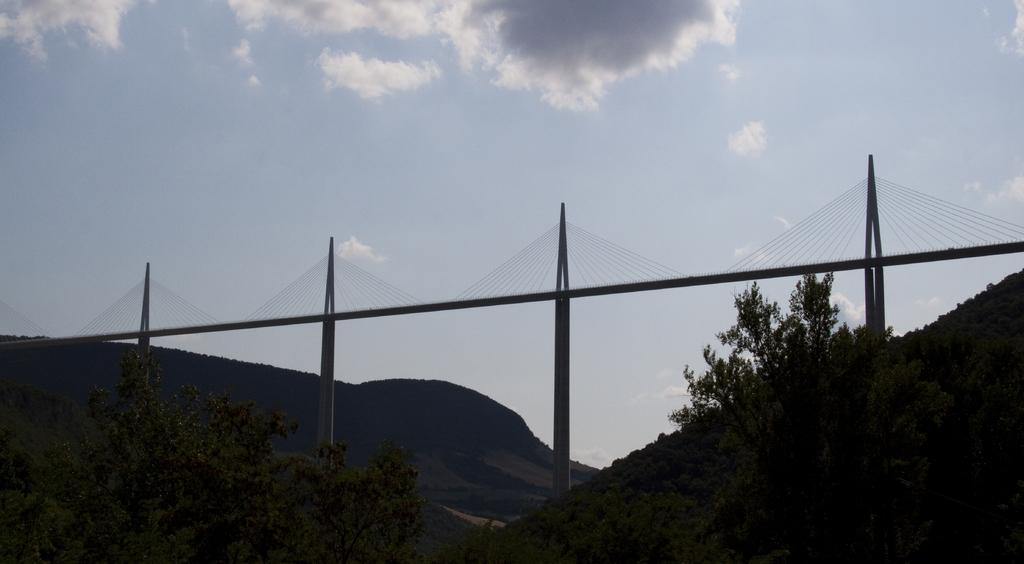What type of natural elements can be seen in the image? There are trees in the image. What man-made structure is present in the image? There is a bridge in the image. What can be seen in the distance in the image? Hills are visible in the background of the image. What is the condition of the sky in the image? The sky is clear, and there are clouds in the sky. Can you hear the thunder in the image? There is no sound present in the image, so it is not possible to hear any thunder. Is there a house visible in the image? There is no house mentioned in the provided facts, so it cannot be confirmed if a house is present in the image. 